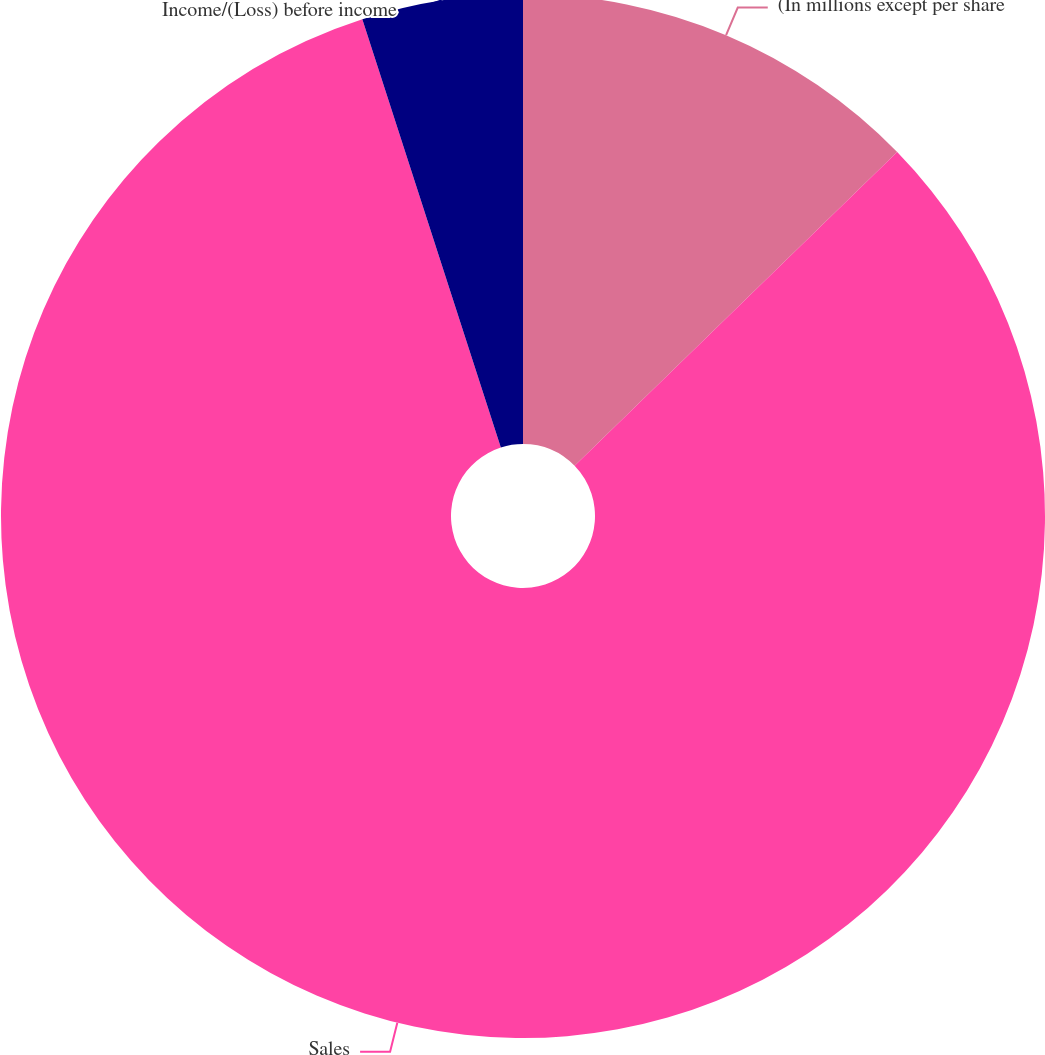Convert chart. <chart><loc_0><loc_0><loc_500><loc_500><pie_chart><fcel>(In millions except per share<fcel>Sales<fcel>Income/(Loss) before income<nl><fcel>12.72%<fcel>82.3%<fcel>4.98%<nl></chart> 